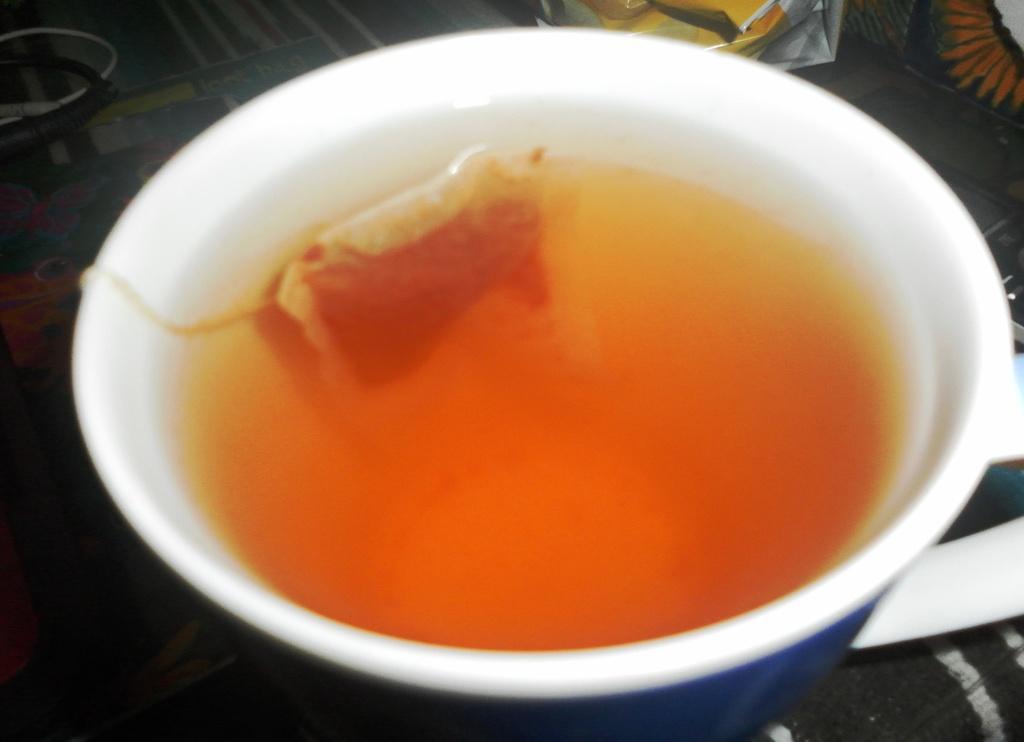Could you give a brief overview of what you see in this image? In this image there is a table with a tablecloth and a cup of tea on it. 